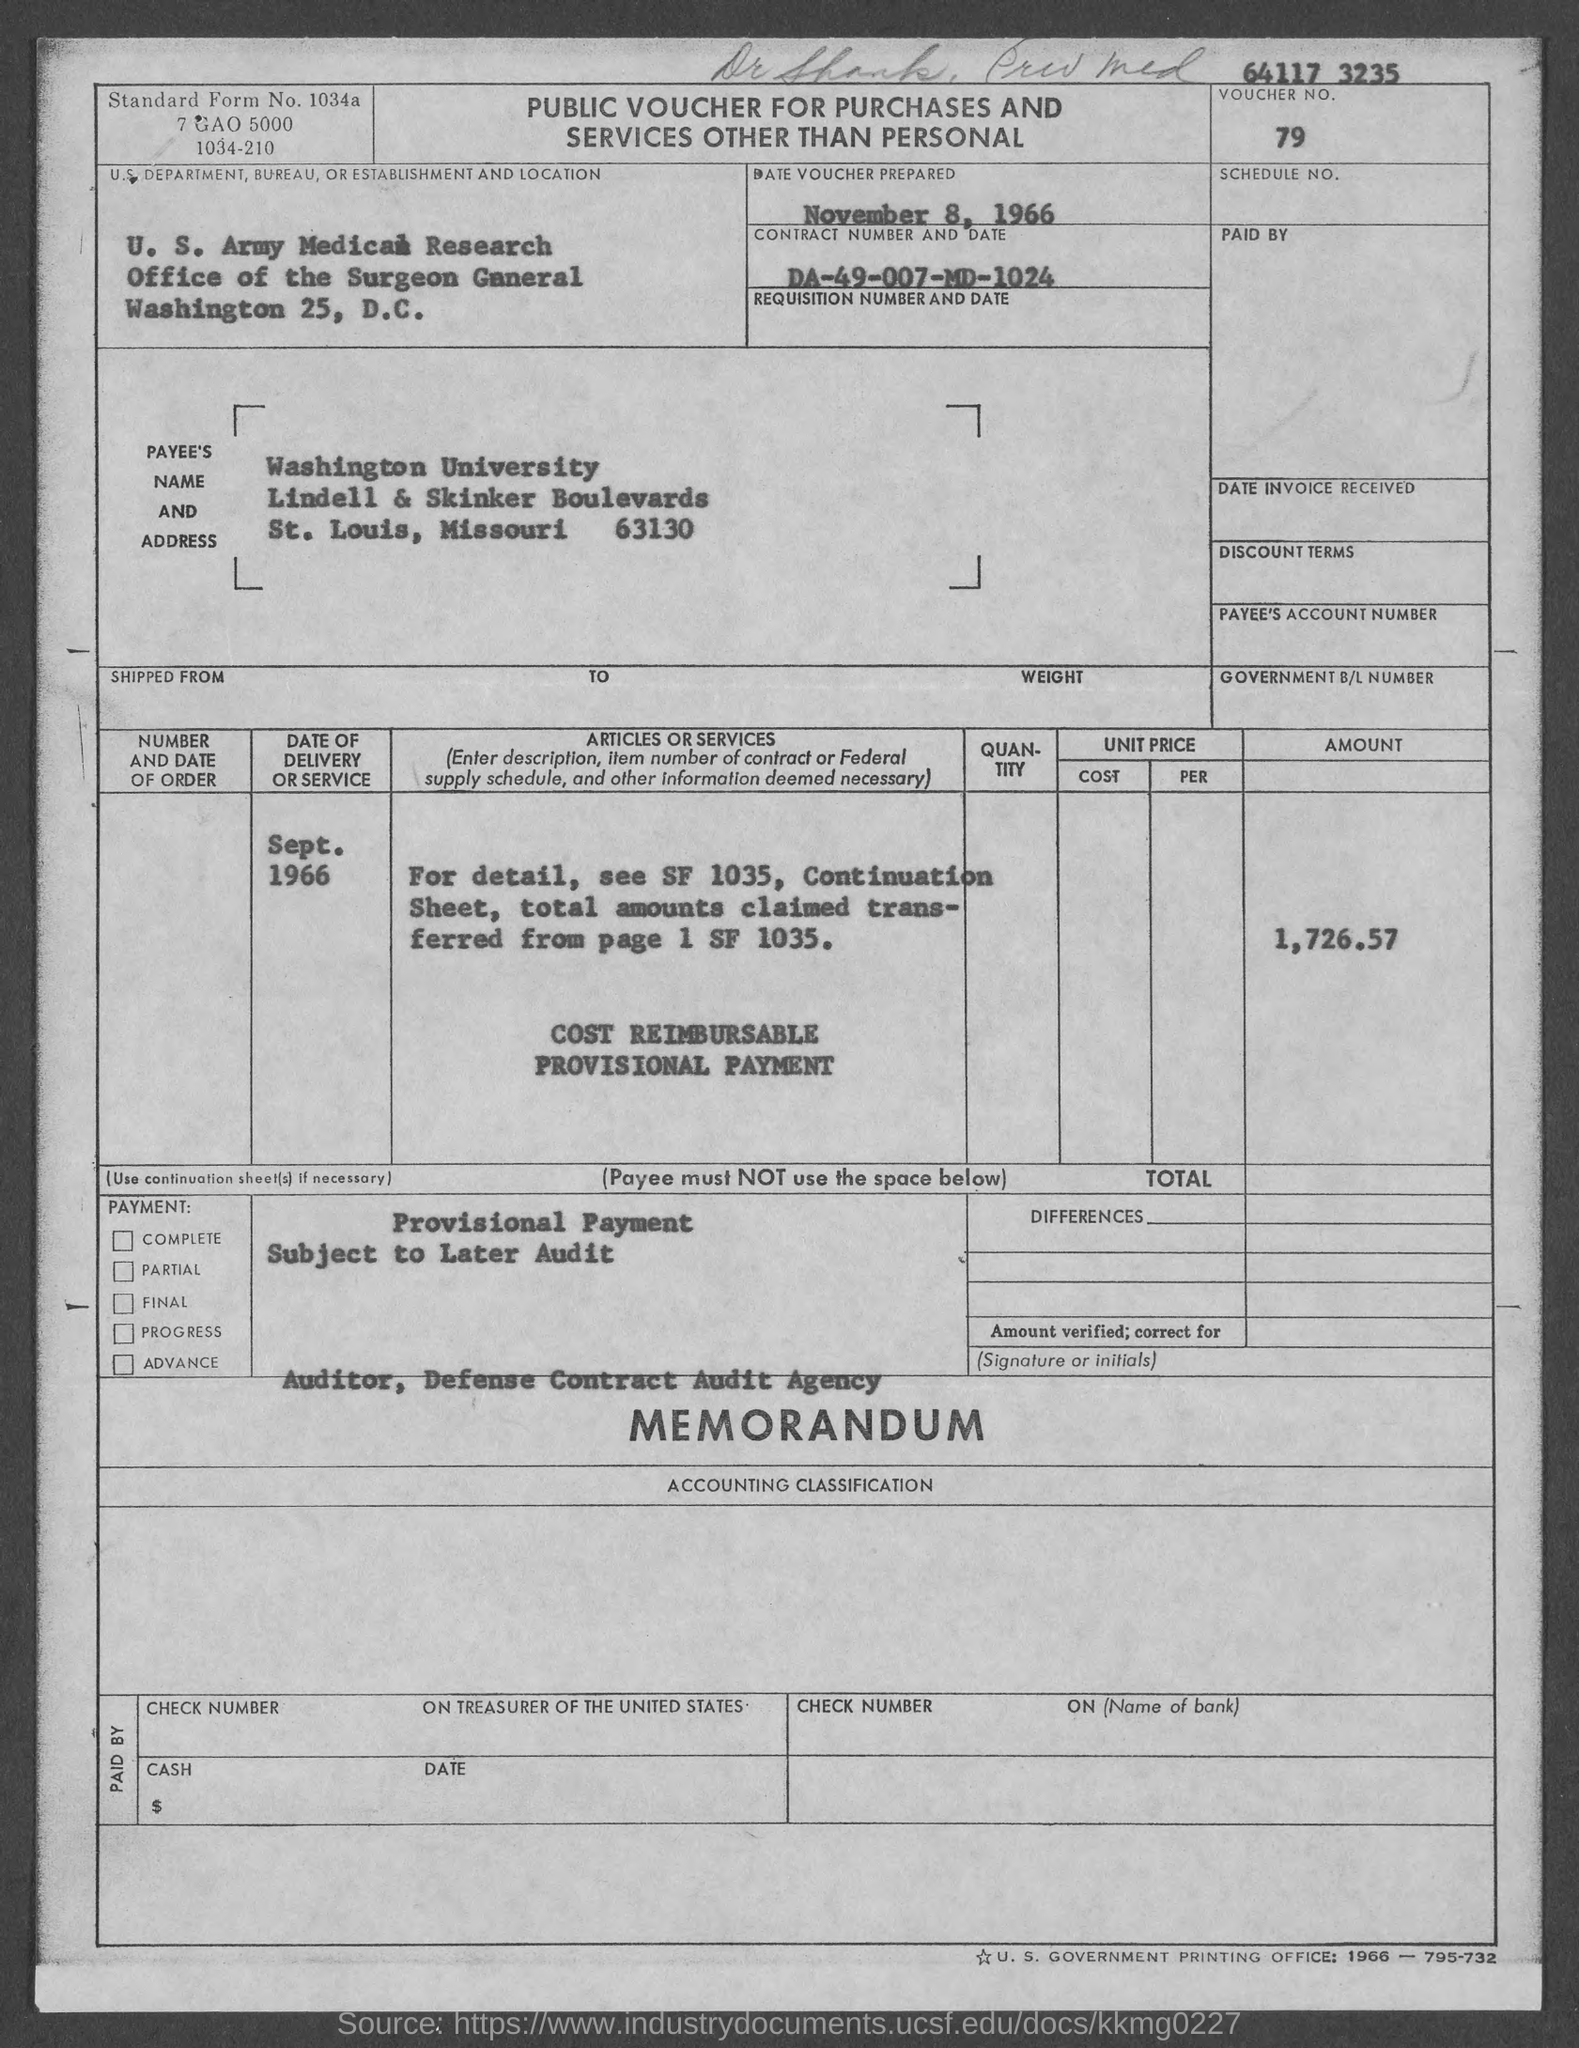What type of voucher is given here?
Your answer should be very brief. PUBLIC VOUCHER. What is the Standard Form No. given in the voucher?
Your answer should be very brief. 1034a. What is the voucher number given in the document?
Your answer should be very brief. 79. What is the date of voucher prepared?
Ensure brevity in your answer.  November 8, 1966. What is the contract number and date given in the voucher?
Keep it short and to the point. DA-49-007-MD-1024. What is the Payee name given in the voucher?
Give a very brief answer. Washington university. What is the total amount mentioned in the voucher?
Offer a terse response. 1,726.57. What is the date of delivery of service mentioned in the voucher?
Your answer should be compact. SEPT. 1966. 